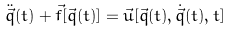<formula> <loc_0><loc_0><loc_500><loc_500>\ddot { \vec { q } } ( t ) + \vec { f } [ \vec { q } ( t ) ] = \vec { u } [ \vec { q } ( t ) , \dot { \vec { q } } ( t ) , t ]</formula> 